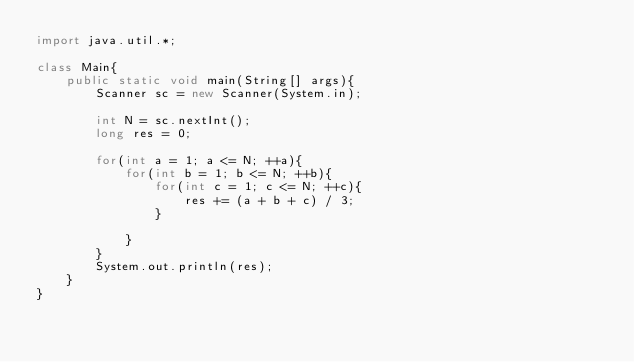<code> <loc_0><loc_0><loc_500><loc_500><_Java_>import java.util.*;
 
class Main{
    public static void main(String[] args){
        Scanner sc = new Scanner(System.in);
 
        int N = sc.nextInt();
        long res = 0;
        
        for(int a = 1; a <= N; ++a){
            for(int b = 1; b <= N; ++b){
                for(int c = 1; c <= N; ++c){
                    res += (a + b + c) / 3;
                }
 
            }
        }
        System.out.println(res);
    }
}</code> 